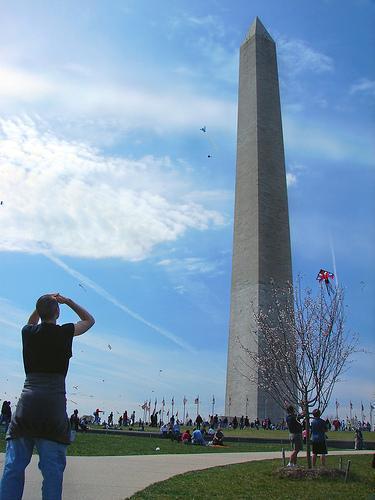How many people are visible?
Give a very brief answer. 2. 